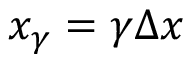<formula> <loc_0><loc_0><loc_500><loc_500>x _ { \gamma } = \gamma x</formula> 